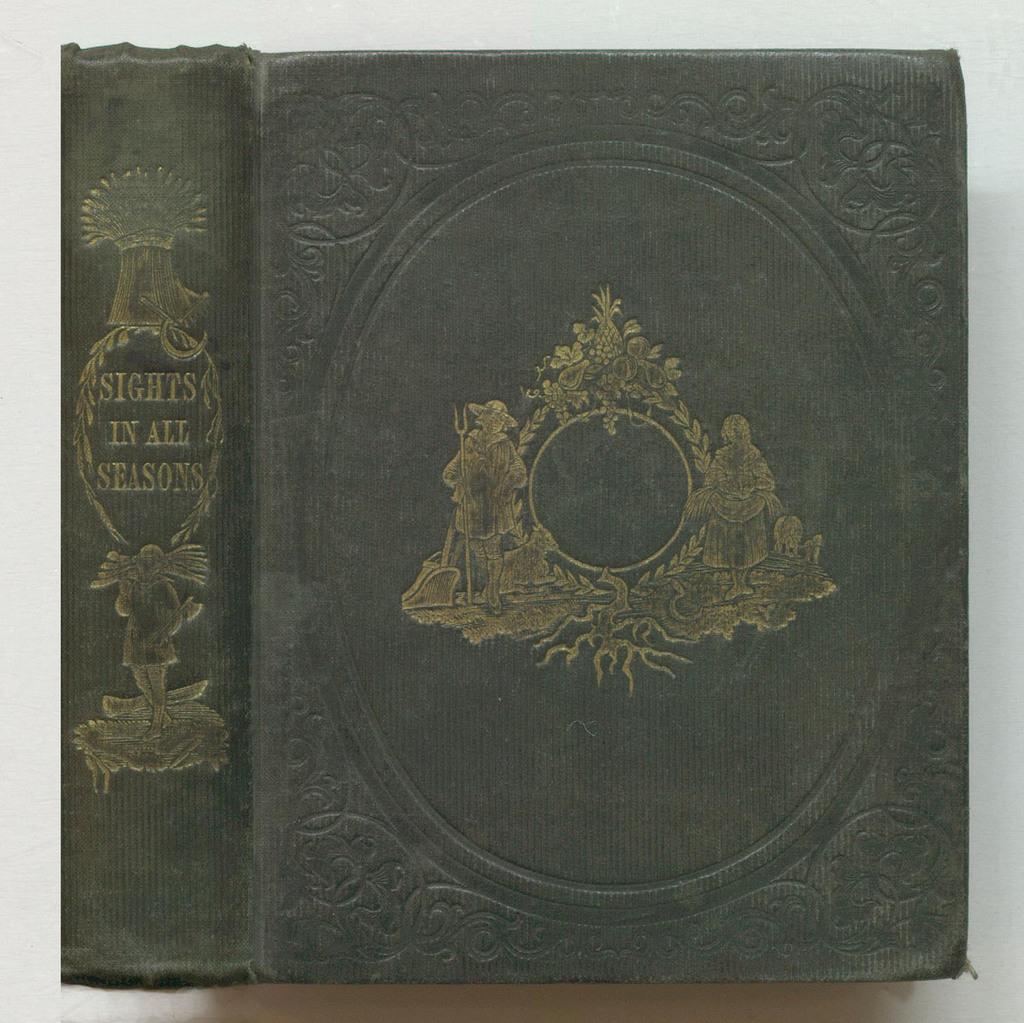What is the title of this book?
Offer a terse response. Sights in all seasons. What is this book showing in all seasons?
Your response must be concise. Sights. 